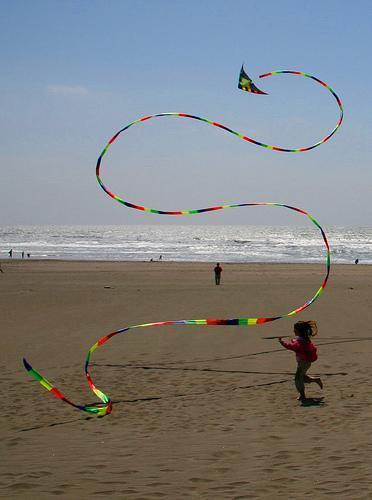How many kites are there?
Give a very brief answer. 1. 